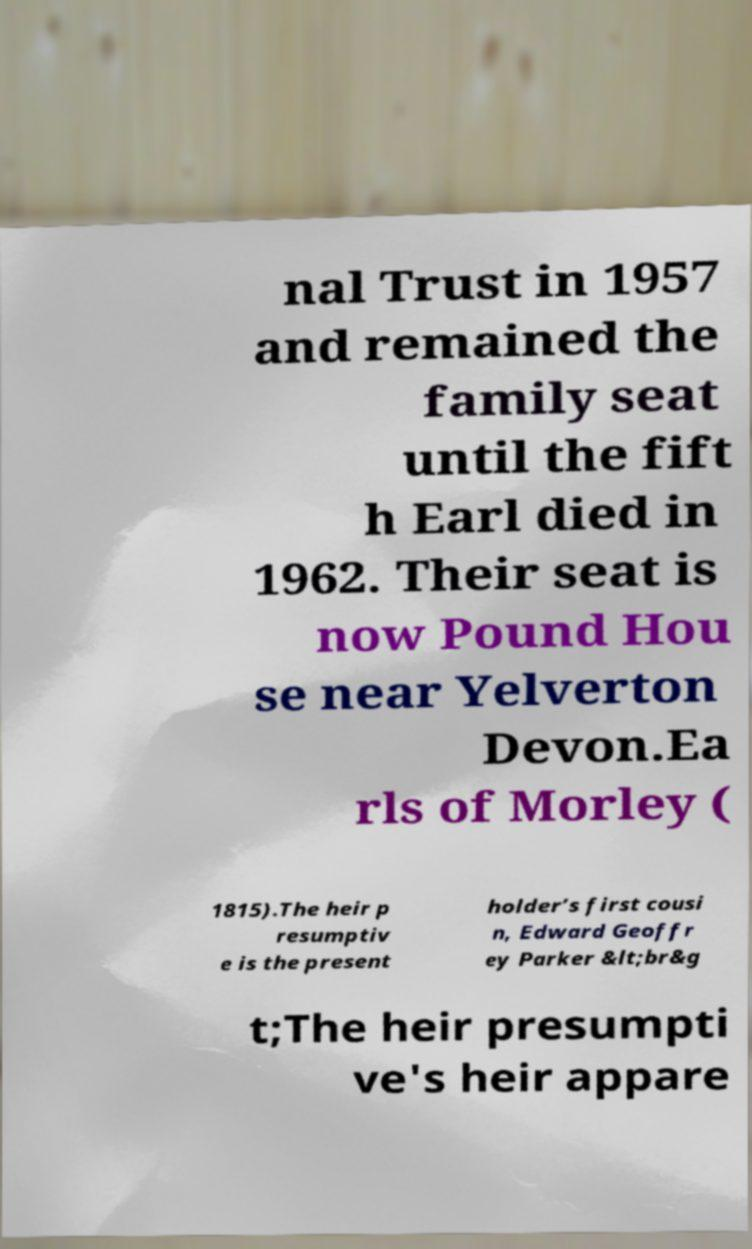What messages or text are displayed in this image? I need them in a readable, typed format. nal Trust in 1957 and remained the family seat until the fift h Earl died in 1962. Their seat is now Pound Hou se near Yelverton Devon.Ea rls of Morley ( 1815).The heir p resumptiv e is the present holder’s first cousi n, Edward Geoffr ey Parker &lt;br&g t;The heir presumpti ve's heir appare 